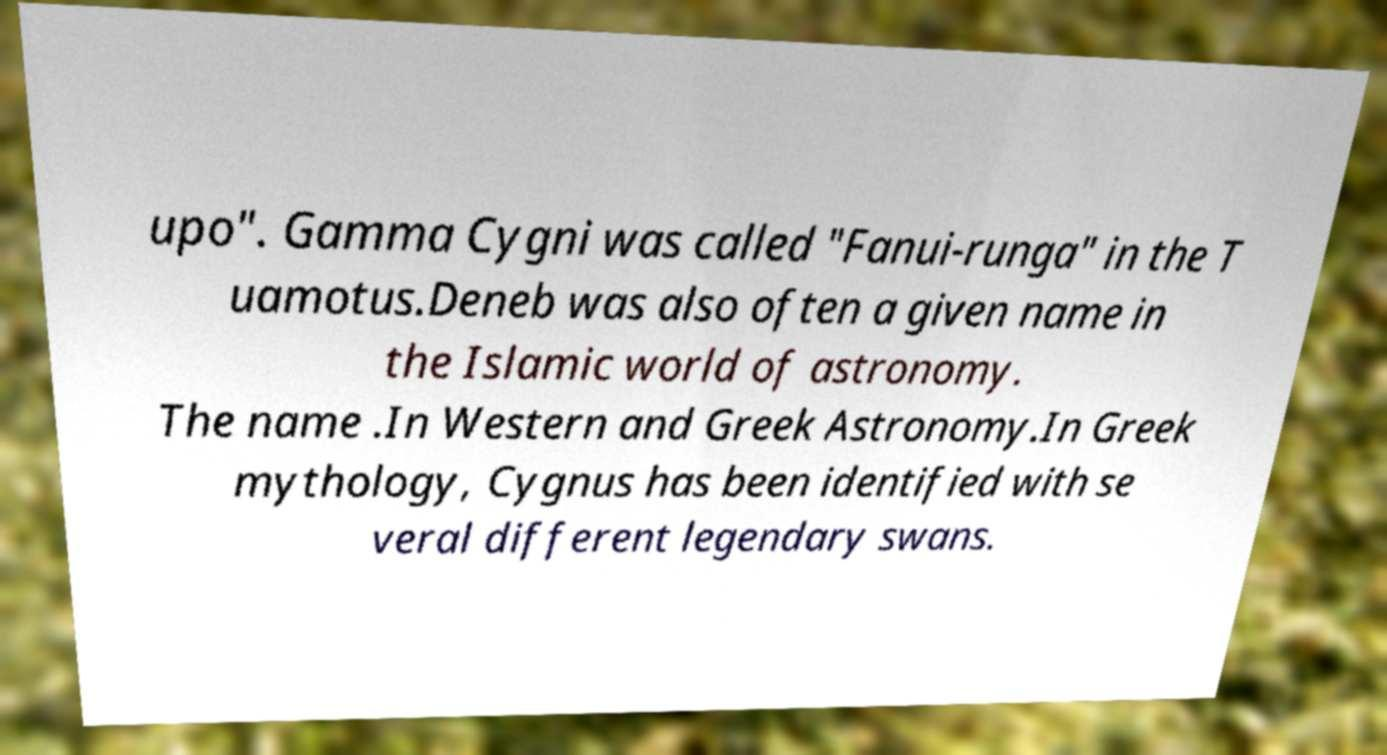For documentation purposes, I need the text within this image transcribed. Could you provide that? upo". Gamma Cygni was called "Fanui-runga" in the T uamotus.Deneb was also often a given name in the Islamic world of astronomy. The name .In Western and Greek Astronomy.In Greek mythology, Cygnus has been identified with se veral different legendary swans. 